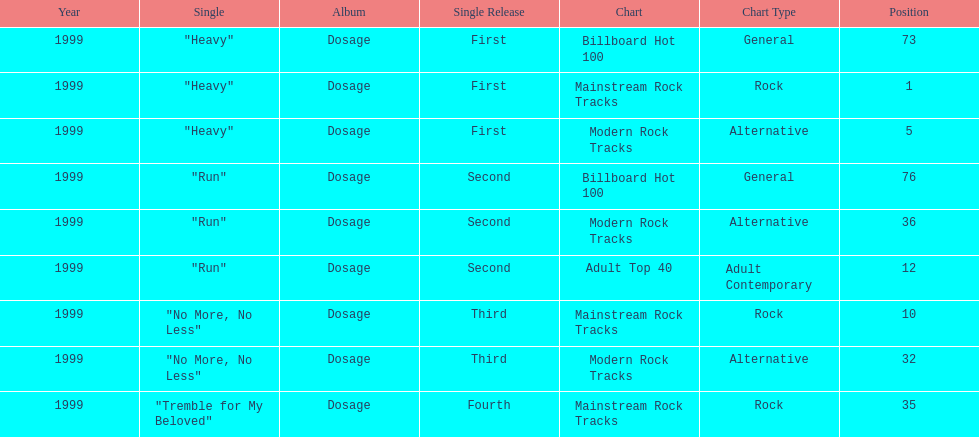Which of the singles from "dosage" had the highest billboard hot 100 rating? "Heavy". 